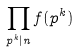Convert formula to latex. <formula><loc_0><loc_0><loc_500><loc_500>\prod _ { p ^ { k } | n } f ( p ^ { k } )</formula> 